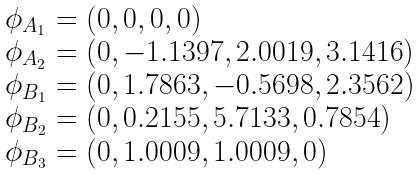<formula> <loc_0><loc_0><loc_500><loc_500>\begin{array} { l } \phi _ { A _ { 1 } } = ( 0 , 0 , 0 , 0 ) \\ \phi _ { A _ { 2 } } = ( 0 , - 1 . 1 3 9 7 , 2 . 0 0 1 9 , 3 . 1 4 1 6 ) \\ \phi _ { B _ { 1 } } = ( 0 , 1 . 7 8 6 3 , - 0 . 5 6 9 8 , 2 . 3 5 6 2 ) \\ \phi _ { B _ { 2 } } = ( 0 , 0 . 2 1 5 5 , 5 . 7 1 3 3 , 0 . 7 8 5 4 ) \\ \phi _ { B _ { 3 } } = ( 0 , 1 . 0 0 0 9 , 1 . 0 0 0 9 , 0 ) \end{array}</formula> 